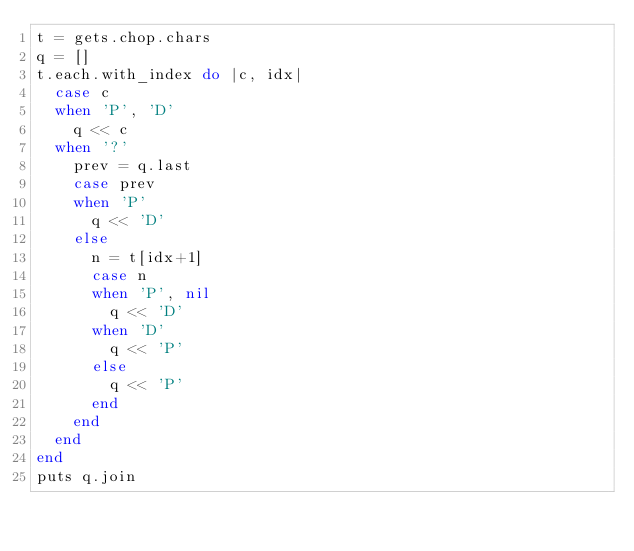Convert code to text. <code><loc_0><loc_0><loc_500><loc_500><_Ruby_>t = gets.chop.chars
q = []
t.each.with_index do |c, idx|
  case c
  when 'P', 'D'
    q << c
  when '?'
    prev = q.last
    case prev
    when 'P'
      q << 'D'
    else
      n = t[idx+1]
      case n
      when 'P', nil
        q << 'D'
      when 'D'
        q << 'P'
      else
        q << 'P'
      end
    end
  end
end
puts q.join</code> 